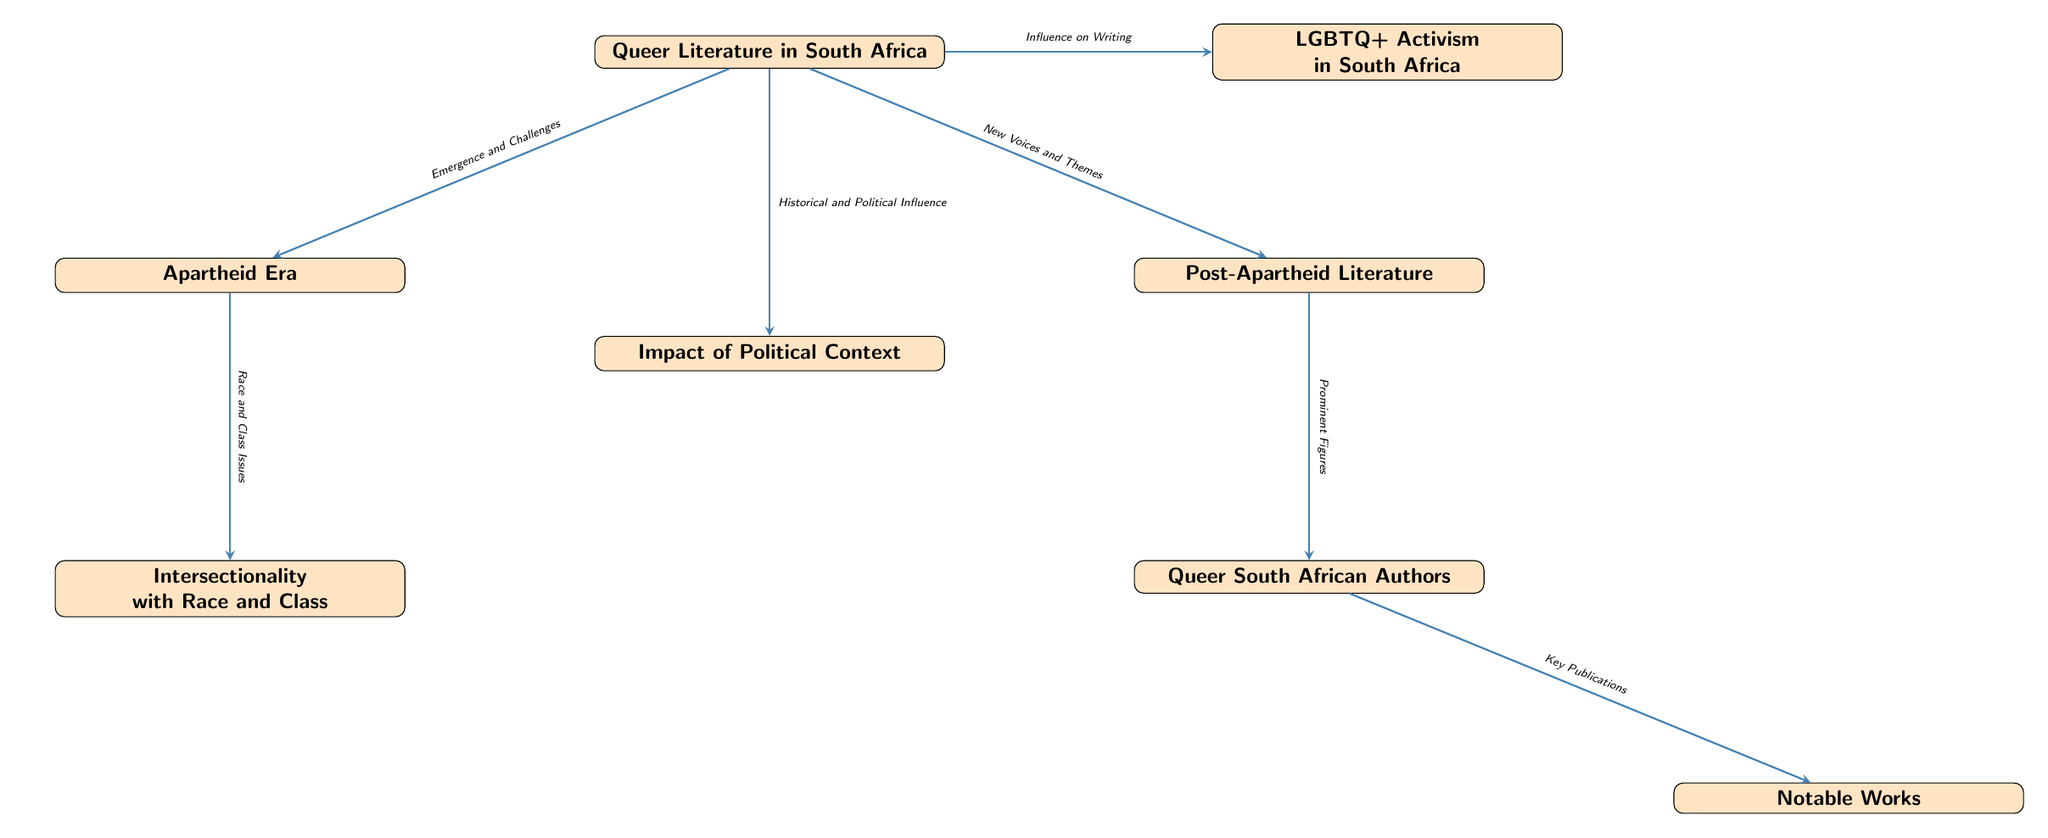What is the main topic of the diagram? The main topic of the diagram is illustrated at the top node, which states "Queer Literature in South Africa." This indicates that the focus is on the intersection of queer identities and their representation within the context of South African literature.
Answer: Queer Literature in South Africa How many main categories are there in the diagram? The diagram includes three primary categories connected to "Queer Literature in South Africa": "Apartheid Era," "Post-Apartheid Literature," and "LGBTQ+ Activism in South Africa." Therefore, the total number of main categories is three.
Answer: 3 What connects "Queer Literature in South Africa" and "LGBTQ+ Activism in South Africa"? The diagram shows a direct connection from "Queer Literature in South Africa" to "LGBTQ+ Activism in South Africa," which is labeled "Influence on Writing." This describes the impact that LGBTQ+ activism has on queer literature in South Africa.
Answer: Influence on Writing What is the relationship between "Post-Apartheid Literature" and "Queer South African Authors"? The relationship between these two nodes is indicated by the edge labeled "Prominent Figures," suggesting that post-apartheid literature features significant contributions from queer South African authors.
Answer: Prominent Figures Which node describes the intersectionality of race and class? The node that describes this intersectionality is labeled "Intersectionality with Race and Class," which is located below "Apartheid Era." This indicates the socio-political dimensions influencing queer literature during the apartheid period.
Answer: Intersectionality with Race and Class What are the notable works linked to "Queer South African Authors"? The diagram indicates that "Notable Works" is linked to "Queer South African Authors" through the edge labeled "Key Publications." This signifies that these authors have produced important literary works recognized within this context.
Answer: Key Publications What type of literature emerged as a challenge during the Apartheid Era? The text on the connection from "Queer Literature in South Africa" to "Apartheid Era" states "Emergence and Challenges," indicating that there were specific challenges faced by queer literature during this period.
Answer: Emergence and Challenges How does the political context affect queer literature? The diagram suggests that the node "Impact of Political Context" directly connects to "Queer Literature in South Africa," implying that the political environment significantly influences the creation and themes in queer literature.
Answer: Impact of Political Context 